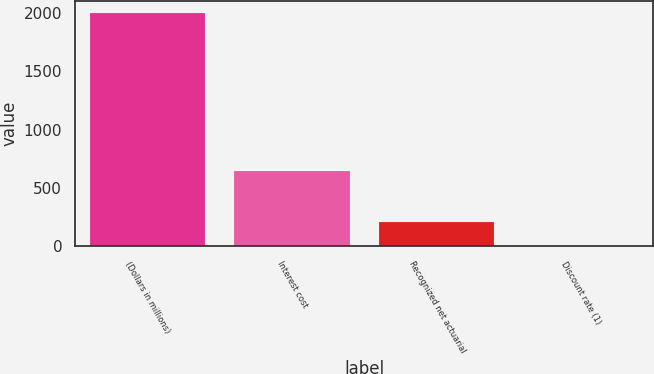Convert chart to OTSL. <chart><loc_0><loc_0><loc_500><loc_500><bar_chart><fcel>(Dollars in millions)<fcel>Interest cost<fcel>Recognized net actuarial<fcel>Discount rate (1)<nl><fcel>2005<fcel>643<fcel>205.68<fcel>5.75<nl></chart> 